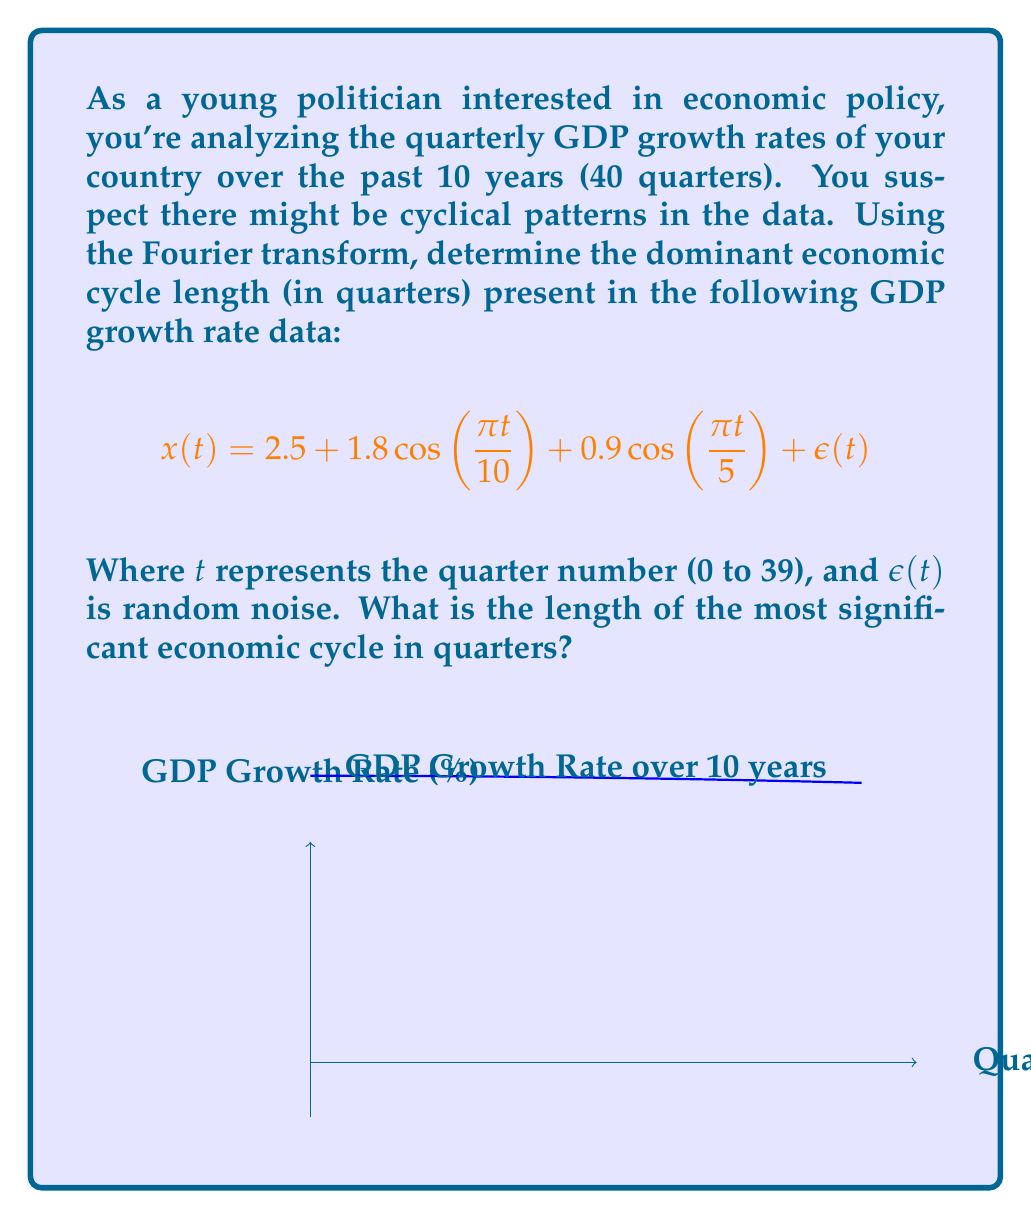Teach me how to tackle this problem. To find the dominant economic cycle, we need to apply the Fourier transform to the given function and identify the frequency with the highest magnitude. Let's approach this step-by-step:

1) The Fourier transform of $x(t)$ is given by:

   $$X(\omega) = \int_{-\infty}^{\infty} x(t)e^{-i\omega t}dt$$

2) We can ignore the constant term (2.5) and the noise term $\epsilon(t)$ as they don't contribute to the cyclical behavior. So we focus on:

   $$x'(t) = 1.8\cos(\frac{\pi t}{10}) + 0.9\cos(\frac{\pi t}{5})$$

3) Using the property of Fourier transform for cosine functions:

   $$\mathcal{F}\{\cos(at)\} = \pi[\delta(\omega-a) + \delta(\omega+a)]$$

4) Applying this to our function:

   $$X'(\omega) = 1.8\pi[\delta(\omega-\frac{\pi}{10}) + \delta(\omega+\frac{\pi}{10})] + 0.9\pi[\delta(\omega-\frac{\pi}{5}) + \delta(\omega+\frac{\pi}{5})]$$

5) The magnitude of each component is proportional to its coefficient:
   - For $\frac{\pi}{10}$ frequency: magnitude = 1.8
   - For $\frac{\pi}{5}$ frequency: magnitude = 0.9

6) The larger magnitude corresponds to the frequency $\frac{\pi}{10}$, which is the dominant cycle.

7) To convert this frequency to cycle length in quarters:
   
   Cycle length = $\frac{2\pi}{\text{frequency}} = \frac{2\pi}{\frac{\pi}{10}} = 20$ quarters

Therefore, the most significant economic cycle has a length of 20 quarters.
Answer: 20 quarters 